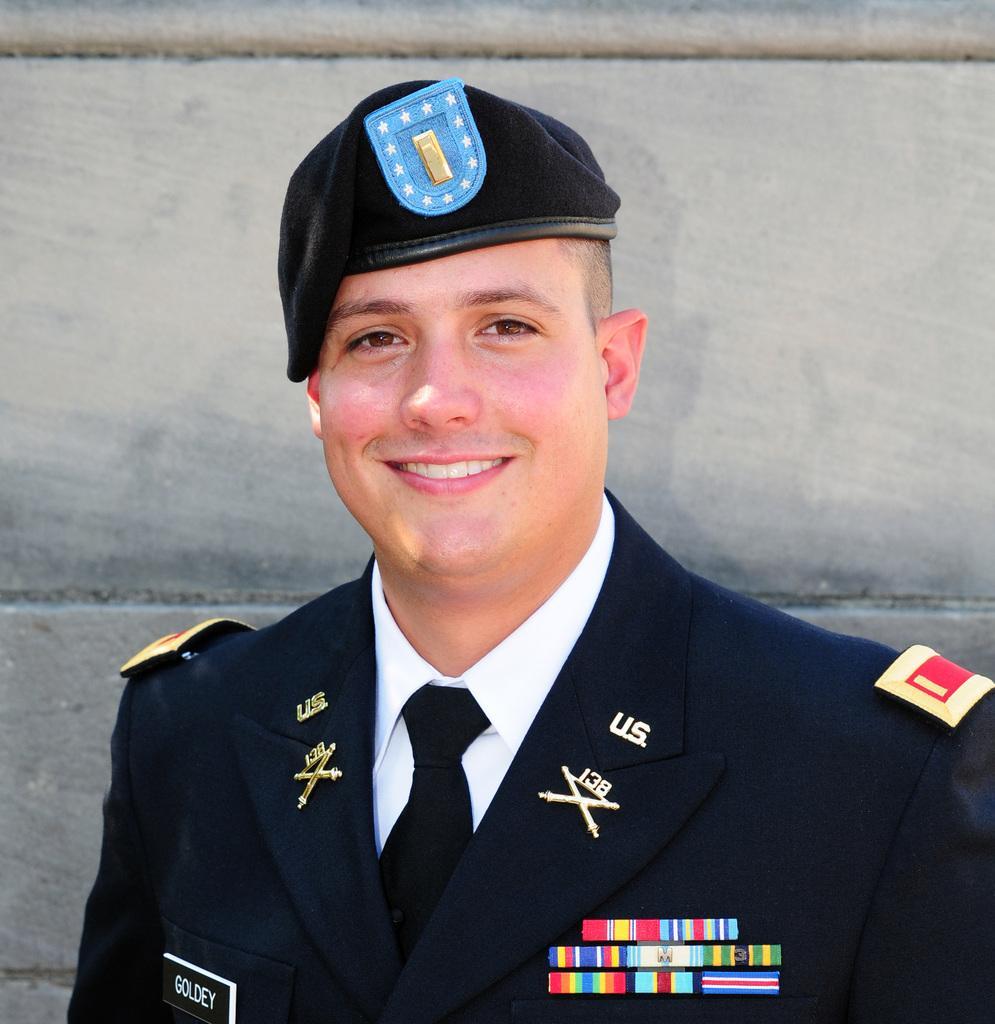Could you give a brief overview of what you see in this image? In this image I can see a person wearing uniform which is in blue and white color. Background the wall is in gray color. 